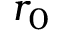Convert formula to latex. <formula><loc_0><loc_0><loc_500><loc_500>r _ { 0 }</formula> 